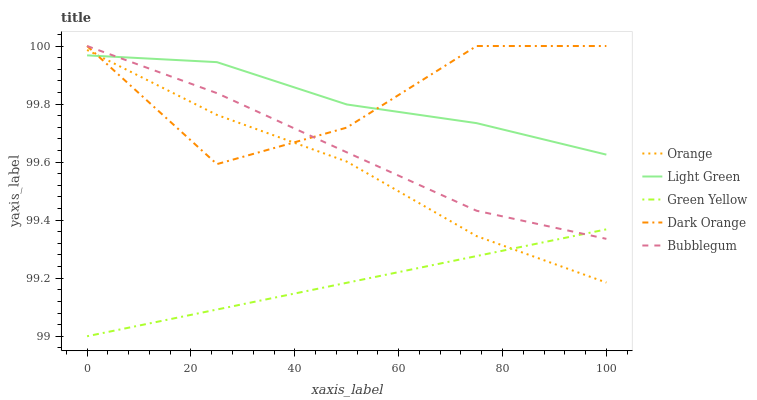Does Green Yellow have the minimum area under the curve?
Answer yes or no. Yes. Does Dark Orange have the maximum area under the curve?
Answer yes or no. Yes. Does Dark Orange have the minimum area under the curve?
Answer yes or no. No. Does Green Yellow have the maximum area under the curve?
Answer yes or no. No. Is Green Yellow the smoothest?
Answer yes or no. Yes. Is Dark Orange the roughest?
Answer yes or no. Yes. Is Dark Orange the smoothest?
Answer yes or no. No. Is Green Yellow the roughest?
Answer yes or no. No. Does Green Yellow have the lowest value?
Answer yes or no. Yes. Does Dark Orange have the lowest value?
Answer yes or no. No. Does Bubblegum have the highest value?
Answer yes or no. Yes. Does Green Yellow have the highest value?
Answer yes or no. No. Is Orange less than Bubblegum?
Answer yes or no. Yes. Is Light Green greater than Green Yellow?
Answer yes or no. Yes. Does Dark Orange intersect Bubblegum?
Answer yes or no. Yes. Is Dark Orange less than Bubblegum?
Answer yes or no. No. Is Dark Orange greater than Bubblegum?
Answer yes or no. No. Does Orange intersect Bubblegum?
Answer yes or no. No. 